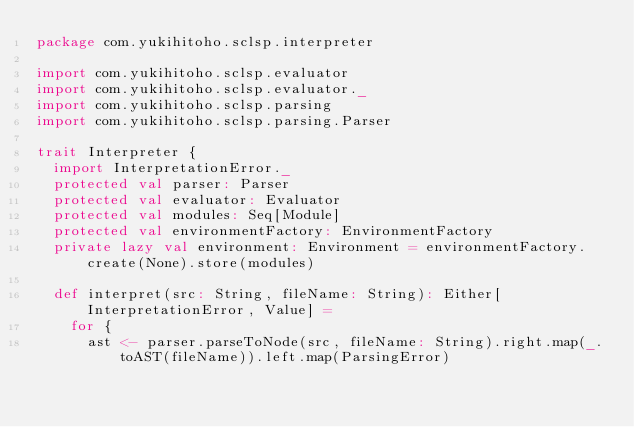<code> <loc_0><loc_0><loc_500><loc_500><_Scala_>package com.yukihitoho.sclsp.interpreter

import com.yukihitoho.sclsp.evaluator
import com.yukihitoho.sclsp.evaluator._
import com.yukihitoho.sclsp.parsing
import com.yukihitoho.sclsp.parsing.Parser

trait Interpreter {
  import InterpretationError._
  protected val parser: Parser
  protected val evaluator: Evaluator
  protected val modules: Seq[Module]
  protected val environmentFactory: EnvironmentFactory
  private lazy val environment: Environment = environmentFactory.create(None).store(modules)

  def interpret(src: String, fileName: String): Either[InterpretationError, Value] =
    for {
      ast <- parser.parseToNode(src, fileName: String).right.map(_.toAST(fileName)).left.map(ParsingError)</code> 